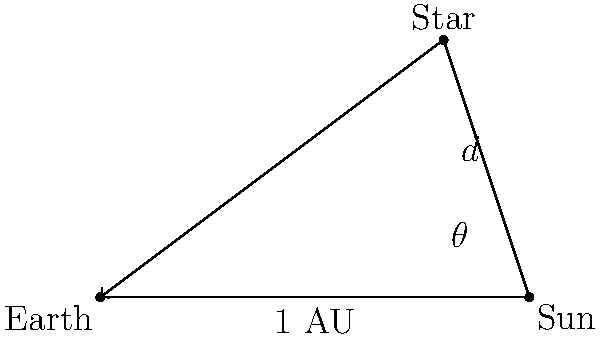During a murder investigation, you come across an astronomy enthusiast's notebook. To verify the victim's alibi, you need to understand a calculation involving stellar parallax. The diagram shows the Earth, Sun, and a distant star forming a right-angled triangle. Given that the Earth-Sun distance (1 AU) is approximately 149.6 million km, and the parallax angle $\theta$ is 0.7 arcseconds, what is the distance $d$ to the star in light-years? To solve this problem, we'll follow these steps:

1) First, we need to convert the parallax angle from arcseconds to radians:
   $\theta_{rad} = \theta_{arcsec} \times \frac{\pi}{180 \times 3600} = 0.7 \times \frac{\pi}{180 \times 3600} \approx 3.39 \times 10^{-6}$ radians

2) In the right-angled triangle, we can use the tangent function:
   $\tan(\theta) = \frac{1 \text{ AU}}{d}$

3) Rearranging this equation:
   $d = \frac{1 \text{ AU}}{\tan(\theta)}$

4) For small angles, $\tan(\theta) \approx \theta$ (in radians), so:
   $d \approx \frac{1 \text{ AU}}{\theta_{rad}} = \frac{1}{3.39 \times 10^{-6}} \text{ AU} \approx 2.95 \times 10^5 \text{ AU}$

5) Convert AU to km:
   $d \approx 2.95 \times 10^5 \times 149.6 \times 10^6 \text{ km} = 4.41 \times 10^{13} \text{ km}$

6) Convert km to light-years (1 light-year ≈ 9.461 × 10^12 km):
   $d \approx \frac{4.41 \times 10^{13}}{9.461 \times 10^{12}} \text{ light-years} \approx 4.66 \text{ light-years}$
Answer: 4.66 light-years 